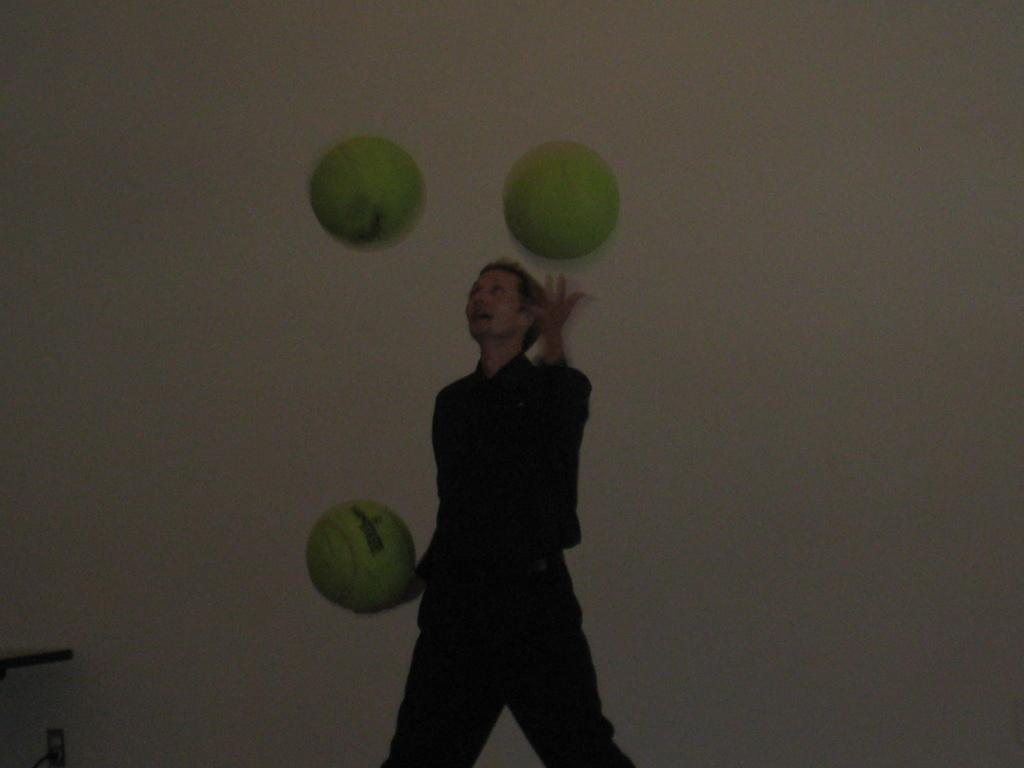Who is present in the image? There is a person in the image. What is the person doing in the image? The person is standing and holding a ball. What might the scene suggest about the person's activity? The scene appears to be play-related, possibly involving a game or sport. What can be seen in the background of the image? There is a wall in the background of the image. What type of meal is being prepared in the image? There is no meal preparation visible in the image; it features a person standing and holding a ball. 